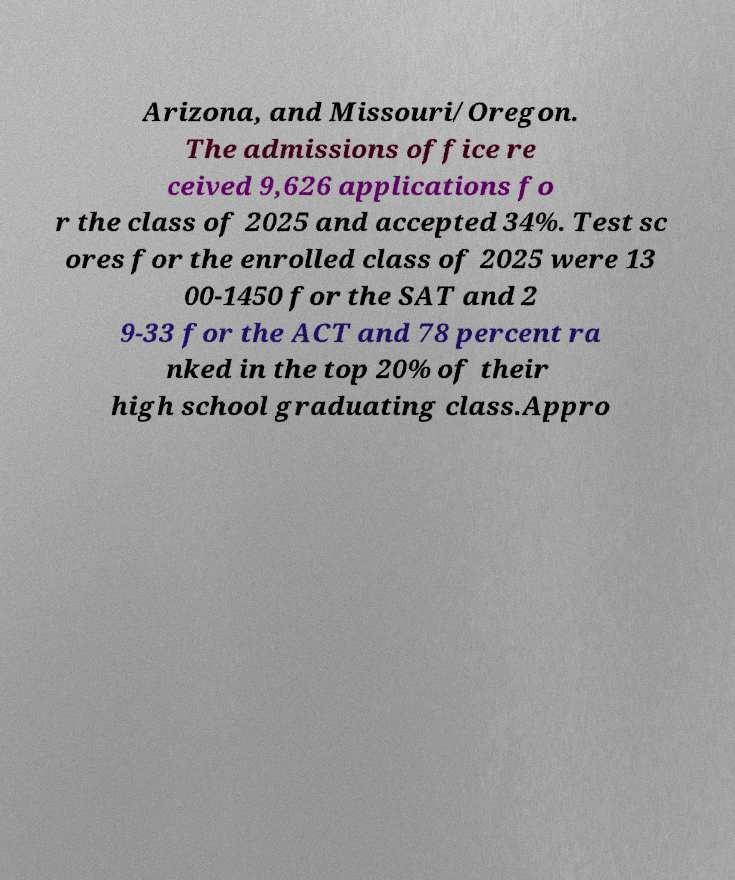I need the written content from this picture converted into text. Can you do that? Arizona, and Missouri/Oregon. The admissions office re ceived 9,626 applications fo r the class of 2025 and accepted 34%. Test sc ores for the enrolled class of 2025 were 13 00-1450 for the SAT and 2 9-33 for the ACT and 78 percent ra nked in the top 20% of their high school graduating class.Appro 